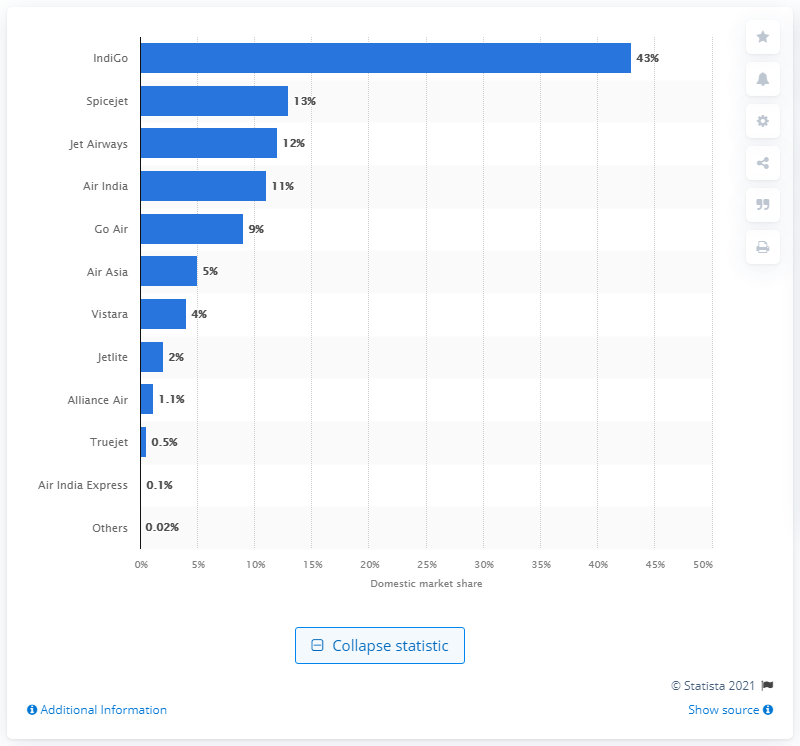Highlight a few significant elements in this photo. As of 2019, IndiGo was the leading passenger carrier in India's aviation segment. 